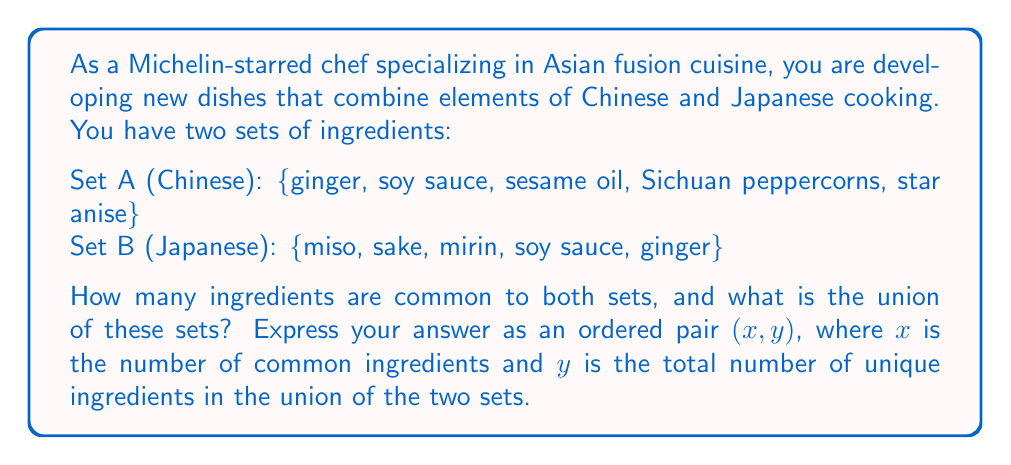Could you help me with this problem? To solve this problem, we need to determine the intersection and union of sets A and B.

1. Find the intersection of sets A and B:
   $A \cap B = \{ginger, soy sauce\}$
   There are 2 common ingredients.

2. Find the union of sets A and B:
   $A \cup B = \{ginger, soy sauce, sesame oil, Sichuan peppercorns, star anise, miso, sake, mirin\}$
   
   To count the number of elements in the union:
   a) Start with all elements in set A: 5
   b) Add elements from set B that are not in A: 3 (miso, sake, mirin)
   
   Total unique ingredients: $5 + 3 = 8$

3. Express the answer as an ordered pair $(x, y)$:
   $x = |A \cap B| = 2$ (number of common ingredients)
   $y = |A \cup B| = 8$ (total number of unique ingredients in the union)

Therefore, the answer is $(2, 8)$.
Answer: $(2, 8)$ 